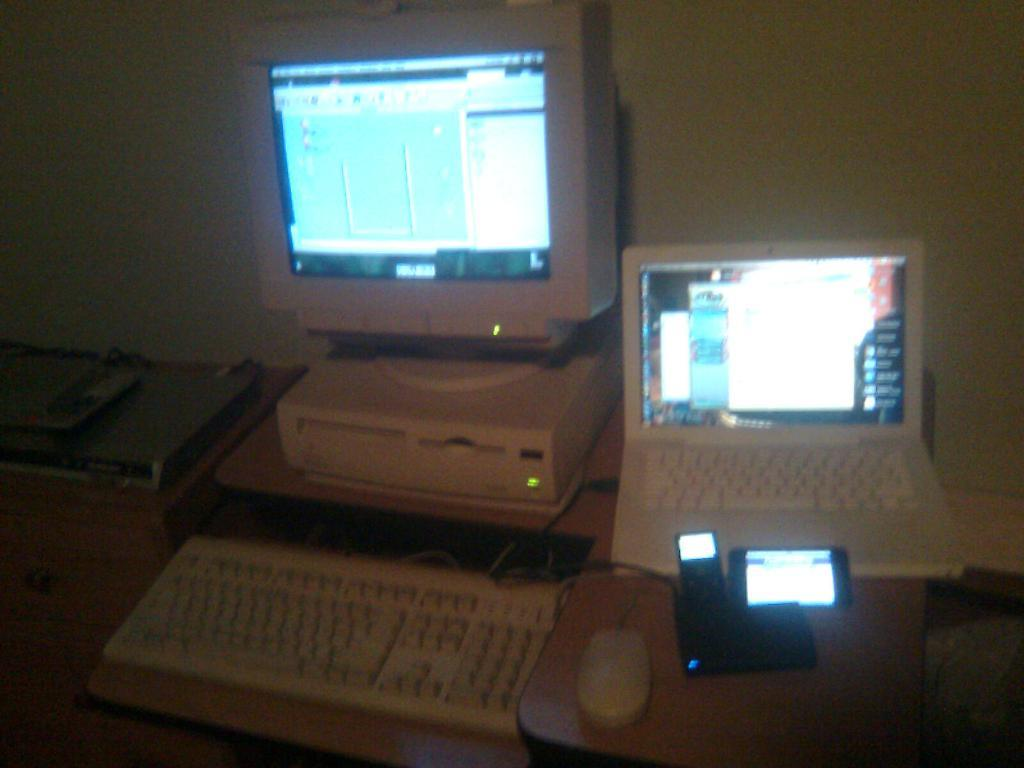What piece of furniture is visible in the image? There is a table in the image. What electronic devices are on the table? A keyboard, a laptop, and a monitor are on the table. What can be seen in the background of the image? There is a wall in the background of the image. How many needles are being used to hammer a chance into the wall in the image? There are no needles, hammers, or chances present in the image. 